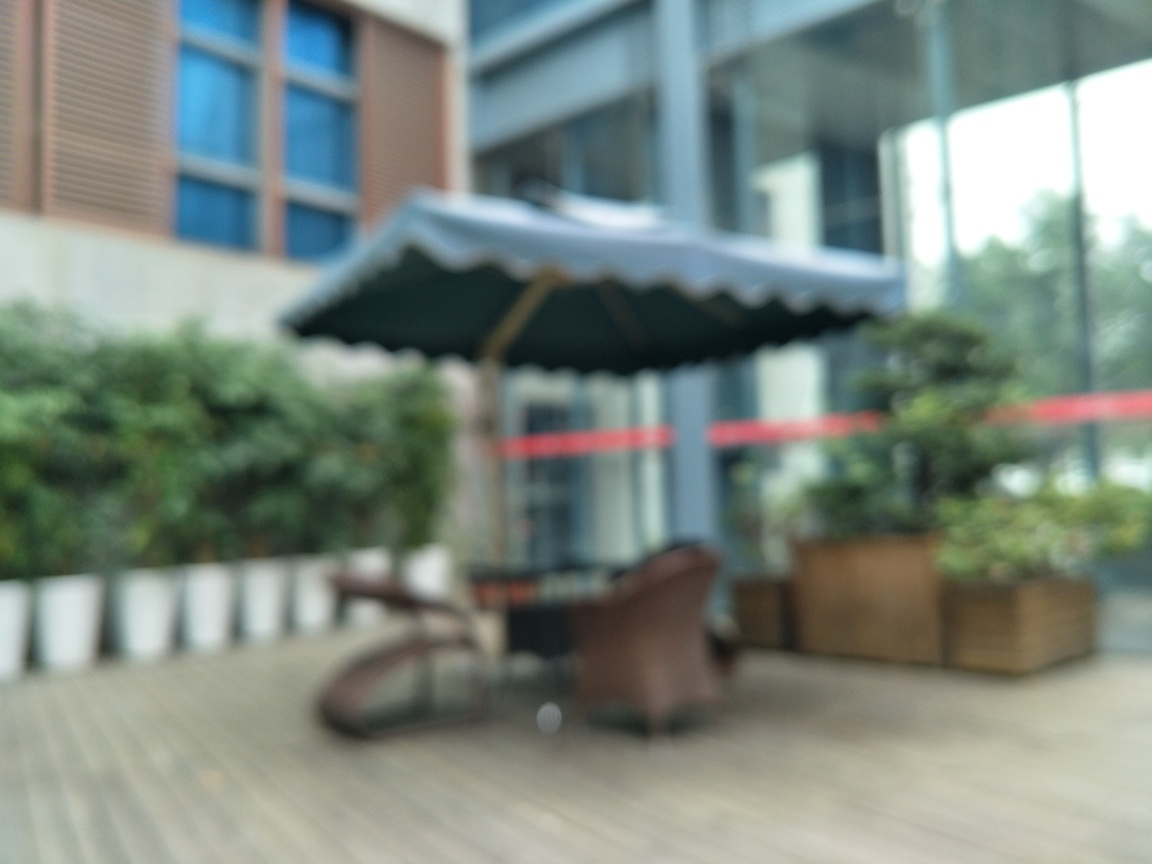Are there identifiable objects or structures that can give us a clue about where this photo was taken? Despite the blurriness, the image suggests an outdoor setting with objects that resemble a patio umbrella, railing, and benches. These elements hint at a public or private outdoor seating area, such as a cafe terrace, a park, or a similar recreational space. 